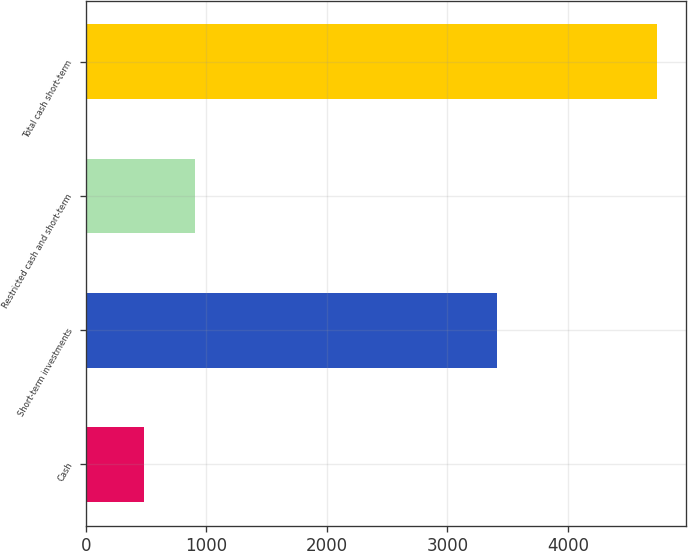Convert chart to OTSL. <chart><loc_0><loc_0><loc_500><loc_500><bar_chart><fcel>Cash<fcel>Short-term investments<fcel>Restricted cash and short-term<fcel>Total cash short-term<nl><fcel>480<fcel>3412<fcel>906.2<fcel>4742<nl></chart> 